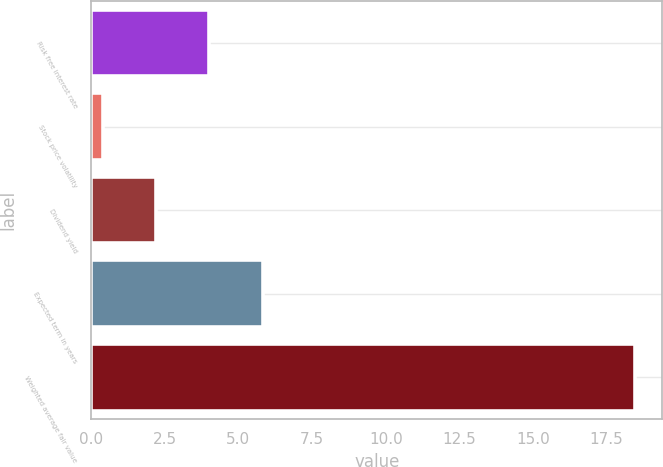Convert chart. <chart><loc_0><loc_0><loc_500><loc_500><bar_chart><fcel>Risk free interest rate<fcel>Stock price volatility<fcel>Dividend yield<fcel>Expected term in years<fcel>Weighted average fair value<nl><fcel>4.01<fcel>0.39<fcel>2.2<fcel>5.82<fcel>18.47<nl></chart> 